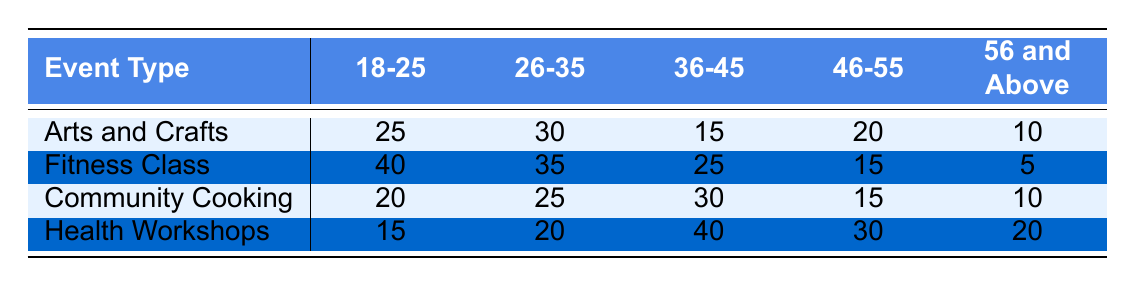What is the total number of participants for the "Fitness Class" event? To find the total number of participants for "Fitness Class", we look at the participants across all age groups: 40 (18-25) + 35 (26-35) + 25 (36-45) + 15 (46-55) + 5 (56 and Above) = 120.
Answer: 120 Which age group has the highest participation in "Community Cooking"? In the "Community Cooking" event, the participants by age group are: 20 (18-25), 25 (26-35), 30 (36-45), 15 (46-55), and 10 (56 and Above). The highest value is 30 participants from the 36-45 age group.
Answer: 36-45 Are there more participants aged 26-35 in "Health Workshops" compared to "Arts and Crafts"? The "Health Workshops" for age group 26-35 has 20 participants, while "Arts and Crafts" has 30 participants in the same age group. Since 20 is less than 30, the answer is no.
Answer: No What is the average participation for the "Arts and Crafts" event across all age groups? To calculate the average for "Arts and Crafts", sum the participants: 25 + 30 + 15 + 20 + 10 = 100. Since there are 5 age groups, the average is 100/5 = 20.
Answer: 20 Which event type has the lowest overall participation from age group "56 and Above"? For the "56 and Above" age group, the participant numbers are: 10 (Arts and Crafts), 5 (Fitness Class), 10 (Community Cooking), and 20 (Health Workshops). The lowest is 5 from the "Fitness Class".
Answer: Fitness Class How many total participants are there in "Health Workshops" for all age groups combined? The total for "Health Workshops" is calculated by adding the participants from each age group: 15 (18-25) + 20 (26-35) + 40 (36-45) + 30 (46-55) + 20 (56 and Above) = 125.
Answer: 125 Does the "Fitness Class" have more participants in the 18-25 age group than "Health Workshops" have in the same group? The "Fitness Class" has 40 participants in the 18-25 age group while "Health Workshops" has 15. Since 40 is greater than 15, the answer is yes.
Answer: Yes What is the difference in participants between the "Arts and Crafts" event and the "Community Cooking" event for the age group 46-55? The "Arts and Crafts" event has 20 participants and "Community Cooking" has 15 participants for the 46-55 age group. The difference is 20 - 15 = 5.
Answer: 5 